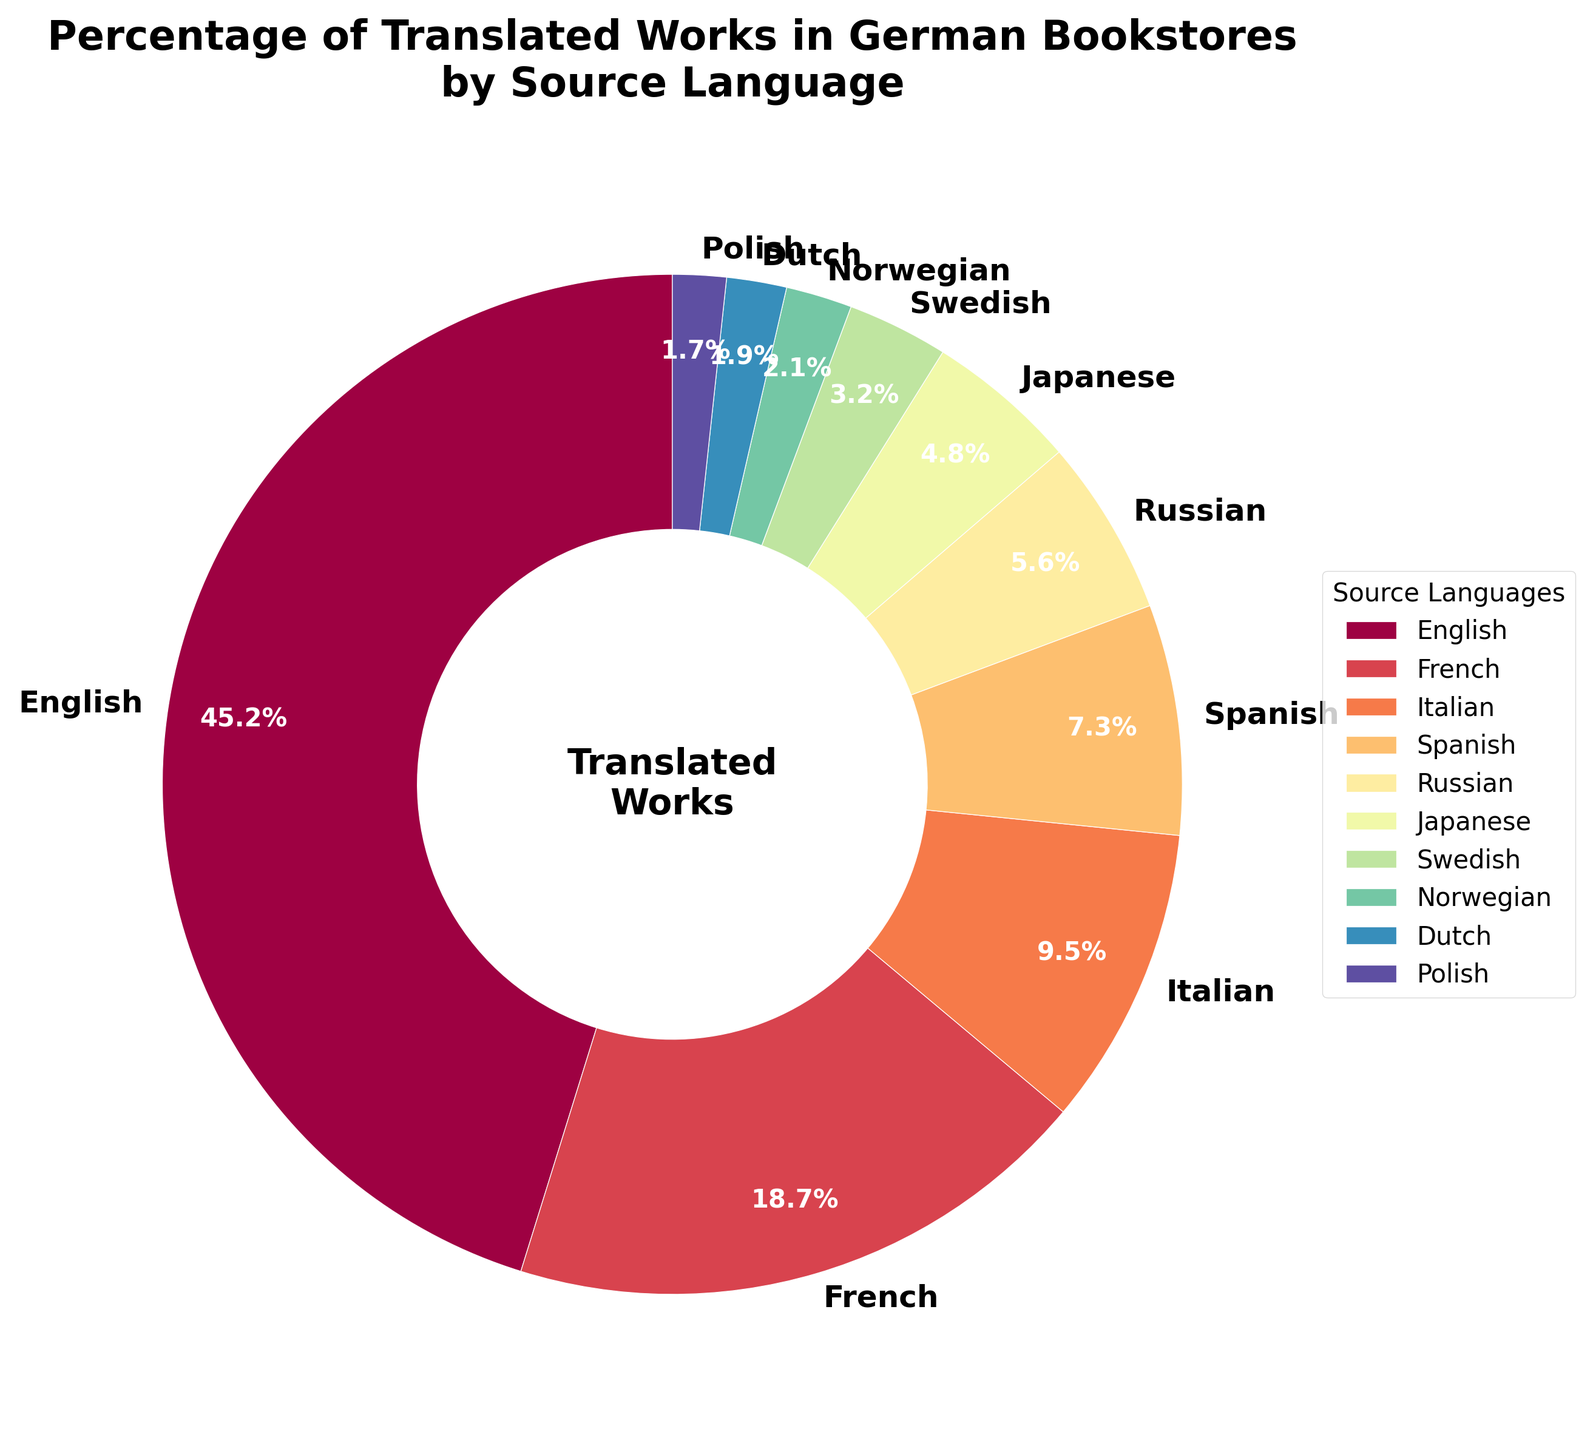What is the source language with the highest percentage of translated works in German bookstores? The pie chart shows that the segment with the label "English" is the largest.
Answer: English What is the combined percentage of translated works from French and Italian source languages? According to the pie chart, French has 18.7% and Italian has 9.5%. Adding these two percentages together: 18.7 + 9.5 = 28.2%.
Answer: 28.2% How does the percentage of translated works from Japanese compare to Spanish? The pie chart indicates that Japanese has 4.8% and Spanish has 7.3%. Thus, Spanish has a higher percentage than Japanese.
Answer: Spanish is higher Which source language has a similar percentage to Russian when compared visually from the pie chart? By visually comparing the widths of the segments, Japanese (4.8%) is quite close to Russian (5.6%).
Answer: Japanese Out of the Scandinavian languages (Swedish and Norwegian), which one has a higher percentage of translated works in German bookstores and by how much? From the pie chart, Swedish is 3.2% and Norwegian is 2.1%. Subtracting these values gives 3.2 - 2.1 = 1.1%.
Answer: Swedish by 1.1% What is the total percentage of translated works from source languages other than English and French? English and French together account for 45.2% + 18.7% = 63.9%. The total percentage being 100%, we subtract to find the rest: 100 - 63.9 = 36.1%.
Answer: 36.1% How does the percentage of translated works from Polish compare with Dutch? According to the pie chart, Polish has 1.7% and Dutch has 1.9%. Therefore, the percentage of translations from Dutch is slightly higher than from Polish.
Answer: Dutch is higher Which source language occupies the smallest segment in the pie chart? Examining the segments, Polish with 1.7% is the smallest.
Answer: Polish What is the average percentage of translated works from Scandinavian languages (Swedish and Norwegian)? The pie chart shows that Swedish is at 3.2% and Norwegian is at 2.1%. The average is calculated by (3.2 + 2.1) / 2 = 2.65%.
Answer: 2.65% Which three source languages together make up approximately half of the translated works in German bookstores? From the pie chart, English (45.2%) and French (18.7%) together is 63.9%, which is beyond half. The third language would be Italian which makes it closer to half with English (45.2%) + Italian (9.5%) + Spanish (7.3%) = 62%. Even though already above, the closest three including German are English, French, and Italian constituting: 45.2% + 18.7% + 9.5% = 73.4%. Thus, the closest languages constituting nearly half are English, French, and Italian.
Answer: English, French, Italian 